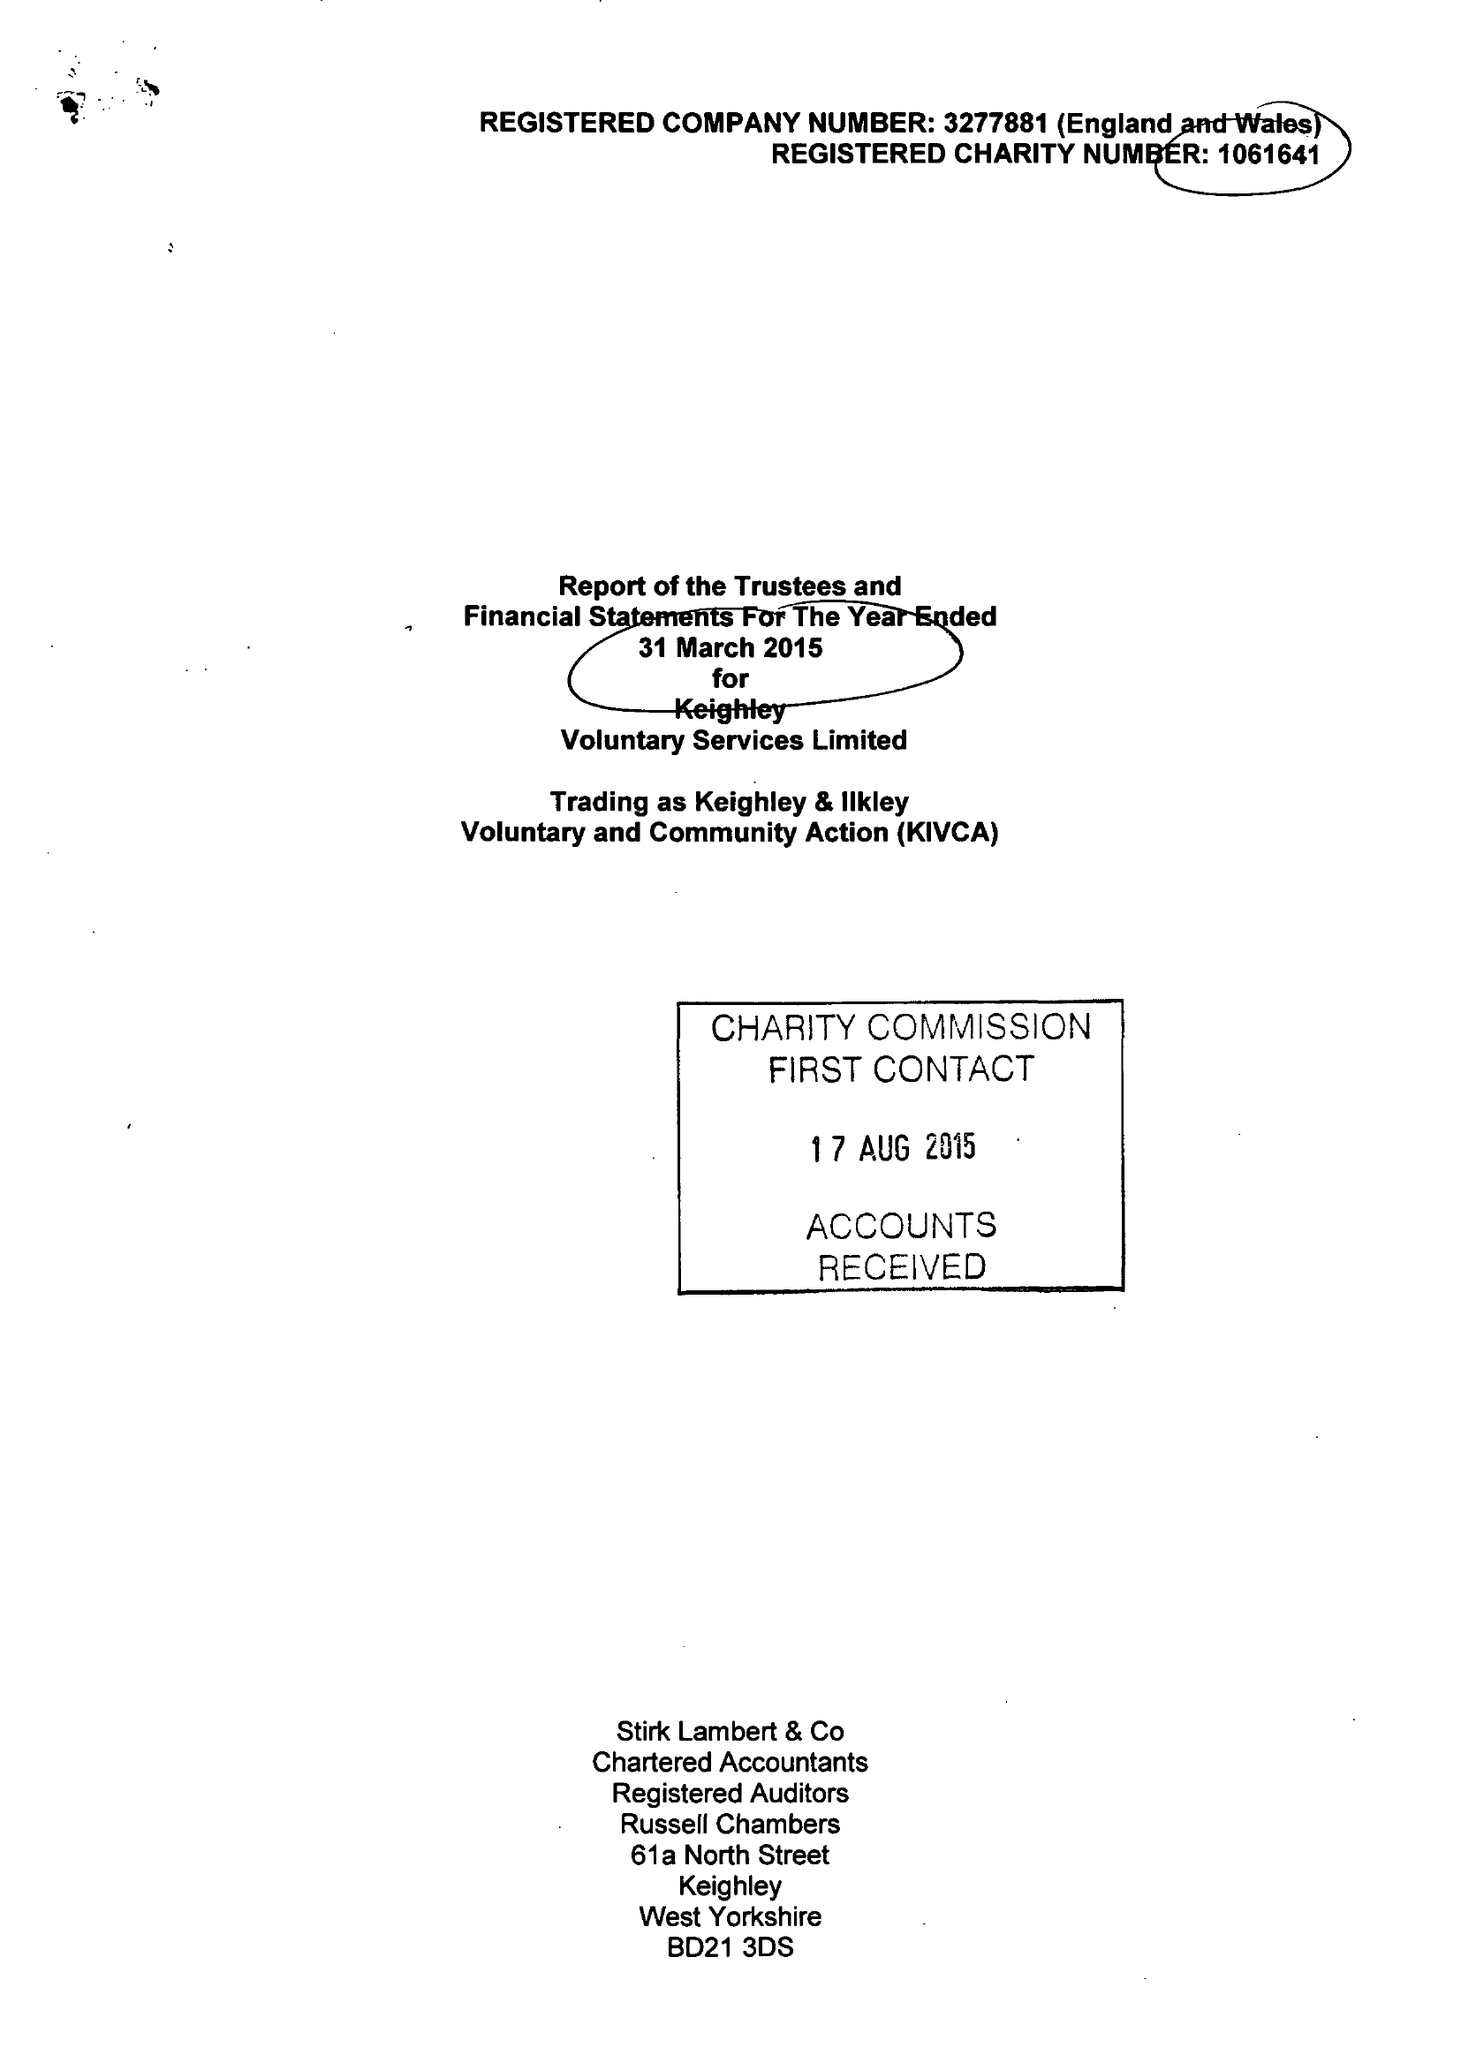What is the value for the address__street_line?
Answer the question using a single word or phrase. ALICE STREET 